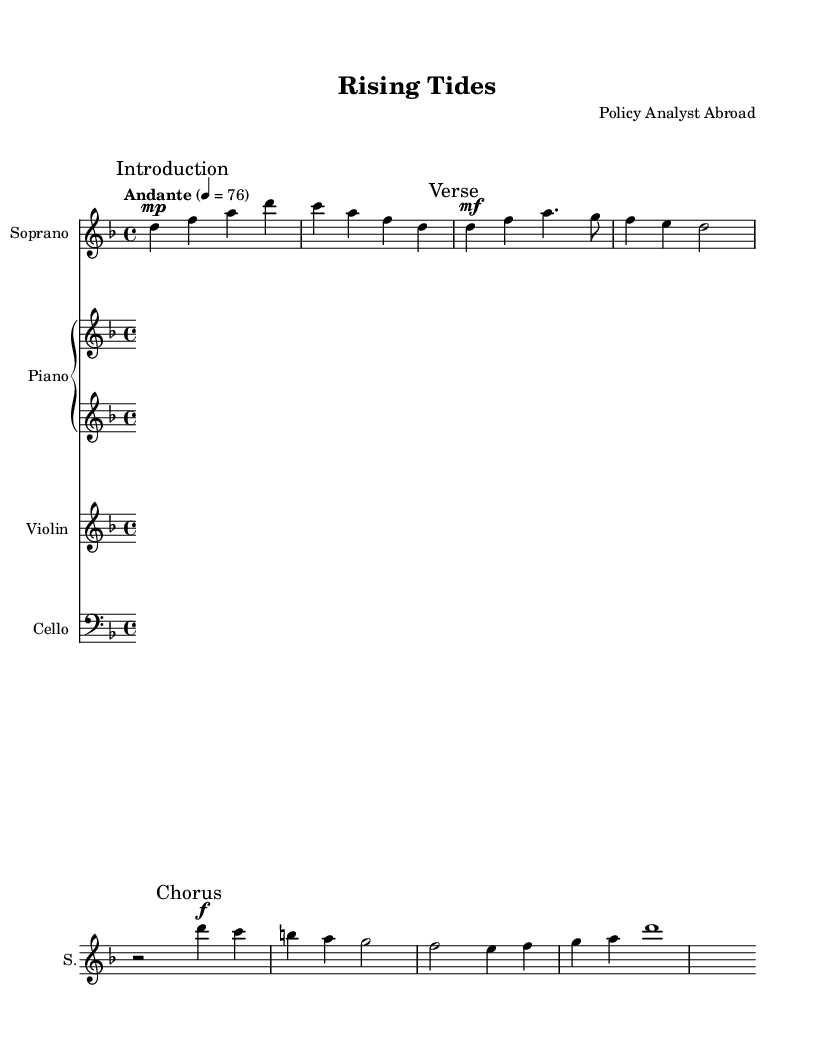What is the key signature of this music? The key signature indicates which notes are sharp or flat throughout the piece. In this case, the key signature shows one flat (B flat), which also indicates that the piece is in D minor.
Answer: D minor What is the time signature of this music? The time signature is found at the beginning of the score. Here, it is shown as 4/4, which means there are four beats in each measure and the quarter note receives one beat.
Answer: 4/4 What is the tempo marking for this piece? The tempo marking is provided in the score to indicate the speed of the music. The score shows "Andante" with a metered speed of 76 beats per minute, signifying a moderately slow pace.
Answer: Andante, 76 How many measures are in the provided music? To find the total number of measures, count the vertical lines separating the sections. There are 5 measures in the Soprano part provided in the snippet.
Answer: 5 What is the primary theme of the lyrics? The lyrics discuss a specific global issue, focusing on the consequences of climate change, particularly rising water levels and melting ice caps, and emphasize the urgency for action.
Answer: Climate change What type of instruments are included in this opera? By examining the score, we can identify the instruments listed: Soprano, Piano (with right and left hand parts), Violin, and Cello, which are typical for an operatic setting.
Answer: Soprano, Piano, Violin, Cello What forms of dynamics are indicated in the music score? The dynamics provide guidance on the volume of the piece. Here, "mp" (mezzo-piano), "mf" (mezzo-forte), and "f" (forte) are used, indicating gradual shifts in intensity during the performance.
Answer: mp, mf, f 